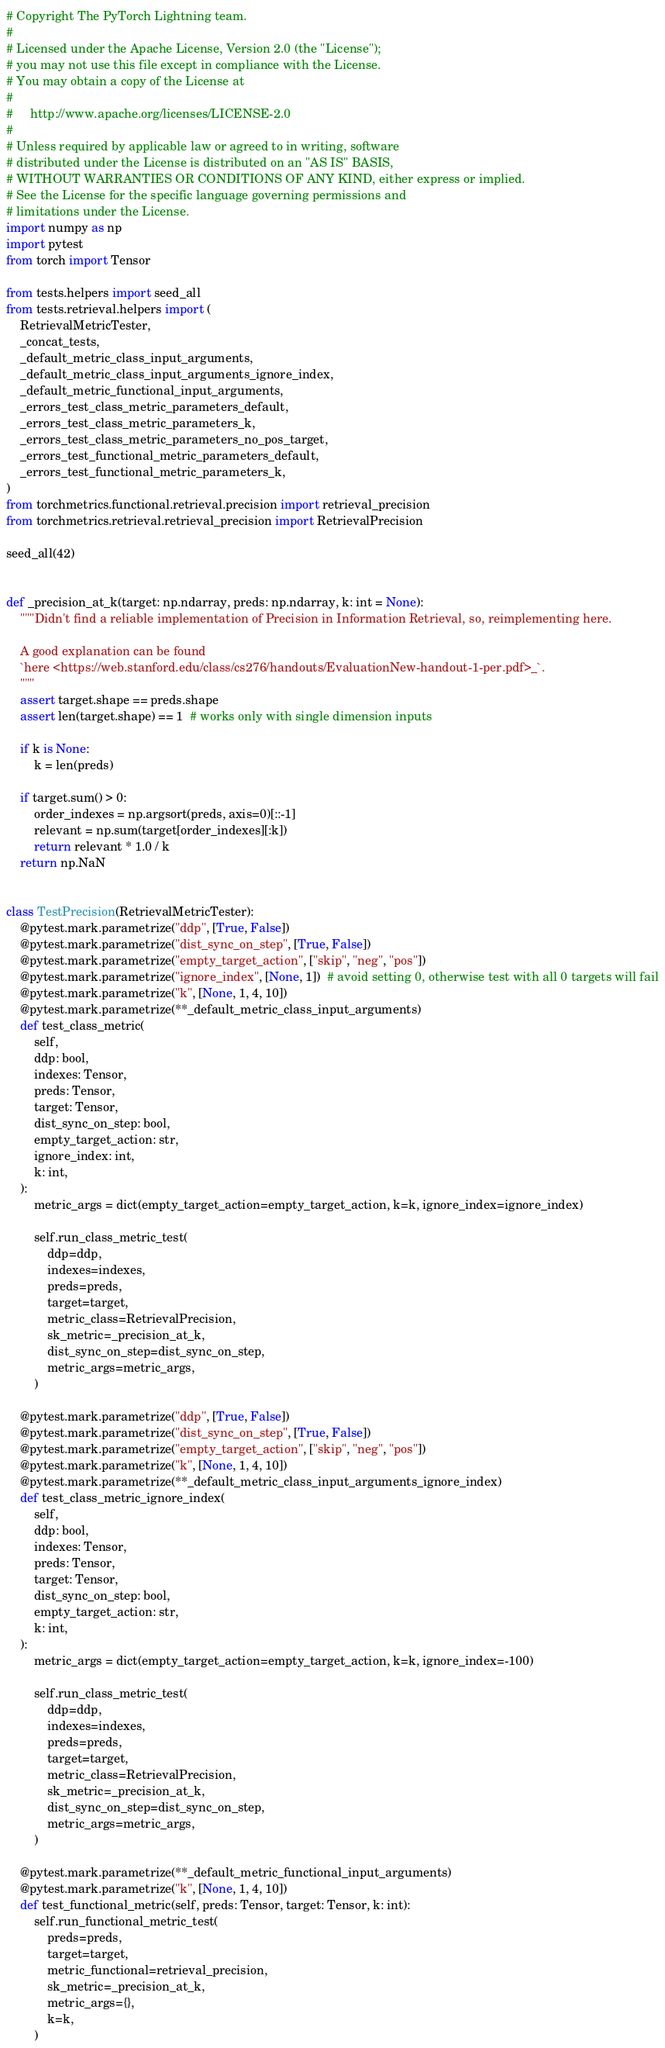<code> <loc_0><loc_0><loc_500><loc_500><_Python_># Copyright The PyTorch Lightning team.
#
# Licensed under the Apache License, Version 2.0 (the "License");
# you may not use this file except in compliance with the License.
# You may obtain a copy of the License at
#
#     http://www.apache.org/licenses/LICENSE-2.0
#
# Unless required by applicable law or agreed to in writing, software
# distributed under the License is distributed on an "AS IS" BASIS,
# WITHOUT WARRANTIES OR CONDITIONS OF ANY KIND, either express or implied.
# See the License for the specific language governing permissions and
# limitations under the License.
import numpy as np
import pytest
from torch import Tensor

from tests.helpers import seed_all
from tests.retrieval.helpers import (
    RetrievalMetricTester,
    _concat_tests,
    _default_metric_class_input_arguments,
    _default_metric_class_input_arguments_ignore_index,
    _default_metric_functional_input_arguments,
    _errors_test_class_metric_parameters_default,
    _errors_test_class_metric_parameters_k,
    _errors_test_class_metric_parameters_no_pos_target,
    _errors_test_functional_metric_parameters_default,
    _errors_test_functional_metric_parameters_k,
)
from torchmetrics.functional.retrieval.precision import retrieval_precision
from torchmetrics.retrieval.retrieval_precision import RetrievalPrecision

seed_all(42)


def _precision_at_k(target: np.ndarray, preds: np.ndarray, k: int = None):
    """Didn't find a reliable implementation of Precision in Information Retrieval, so, reimplementing here.

    A good explanation can be found
    `here <https://web.stanford.edu/class/cs276/handouts/EvaluationNew-handout-1-per.pdf>_`.
    """
    assert target.shape == preds.shape
    assert len(target.shape) == 1  # works only with single dimension inputs

    if k is None:
        k = len(preds)

    if target.sum() > 0:
        order_indexes = np.argsort(preds, axis=0)[::-1]
        relevant = np.sum(target[order_indexes][:k])
        return relevant * 1.0 / k
    return np.NaN


class TestPrecision(RetrievalMetricTester):
    @pytest.mark.parametrize("ddp", [True, False])
    @pytest.mark.parametrize("dist_sync_on_step", [True, False])
    @pytest.mark.parametrize("empty_target_action", ["skip", "neg", "pos"])
    @pytest.mark.parametrize("ignore_index", [None, 1])  # avoid setting 0, otherwise test with all 0 targets will fail
    @pytest.mark.parametrize("k", [None, 1, 4, 10])
    @pytest.mark.parametrize(**_default_metric_class_input_arguments)
    def test_class_metric(
        self,
        ddp: bool,
        indexes: Tensor,
        preds: Tensor,
        target: Tensor,
        dist_sync_on_step: bool,
        empty_target_action: str,
        ignore_index: int,
        k: int,
    ):
        metric_args = dict(empty_target_action=empty_target_action, k=k, ignore_index=ignore_index)

        self.run_class_metric_test(
            ddp=ddp,
            indexes=indexes,
            preds=preds,
            target=target,
            metric_class=RetrievalPrecision,
            sk_metric=_precision_at_k,
            dist_sync_on_step=dist_sync_on_step,
            metric_args=metric_args,
        )

    @pytest.mark.parametrize("ddp", [True, False])
    @pytest.mark.parametrize("dist_sync_on_step", [True, False])
    @pytest.mark.parametrize("empty_target_action", ["skip", "neg", "pos"])
    @pytest.mark.parametrize("k", [None, 1, 4, 10])
    @pytest.mark.parametrize(**_default_metric_class_input_arguments_ignore_index)
    def test_class_metric_ignore_index(
        self,
        ddp: bool,
        indexes: Tensor,
        preds: Tensor,
        target: Tensor,
        dist_sync_on_step: bool,
        empty_target_action: str,
        k: int,
    ):
        metric_args = dict(empty_target_action=empty_target_action, k=k, ignore_index=-100)

        self.run_class_metric_test(
            ddp=ddp,
            indexes=indexes,
            preds=preds,
            target=target,
            metric_class=RetrievalPrecision,
            sk_metric=_precision_at_k,
            dist_sync_on_step=dist_sync_on_step,
            metric_args=metric_args,
        )

    @pytest.mark.parametrize(**_default_metric_functional_input_arguments)
    @pytest.mark.parametrize("k", [None, 1, 4, 10])
    def test_functional_metric(self, preds: Tensor, target: Tensor, k: int):
        self.run_functional_metric_test(
            preds=preds,
            target=target,
            metric_functional=retrieval_precision,
            sk_metric=_precision_at_k,
            metric_args={},
            k=k,
        )
</code> 